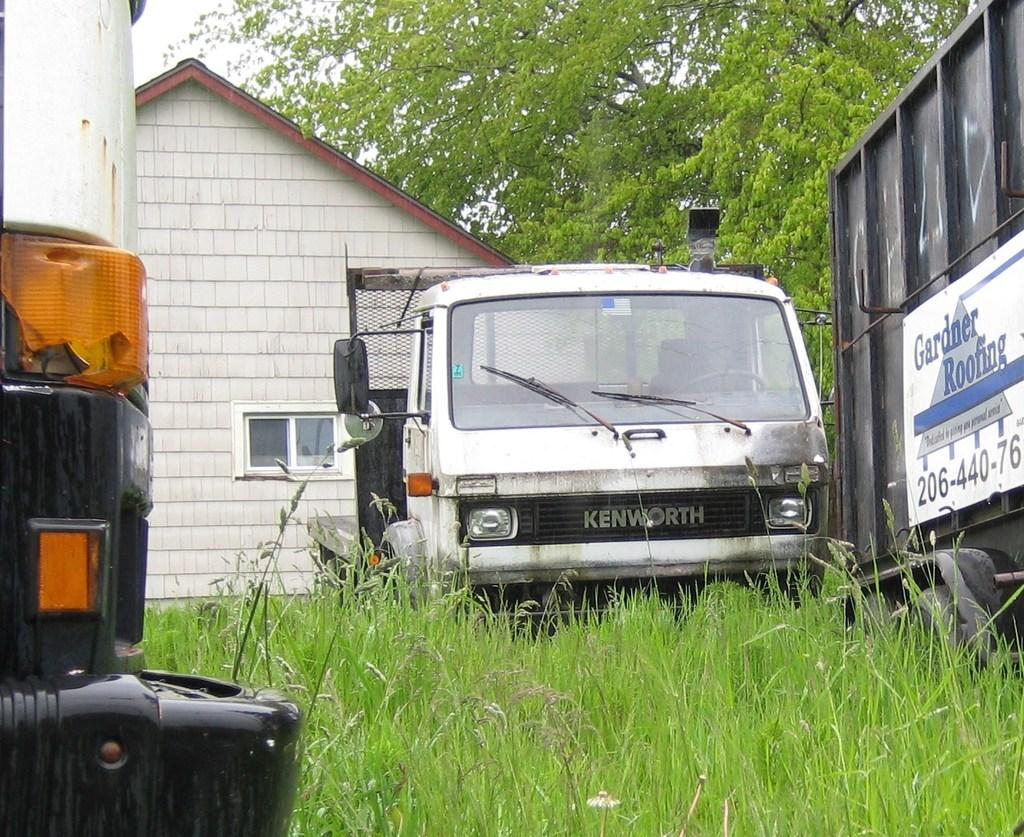<image>
Summarize the visual content of the image. A dumpster with a logo for Gardner Roofing sits in an overgrown yard in front of a run down house. 